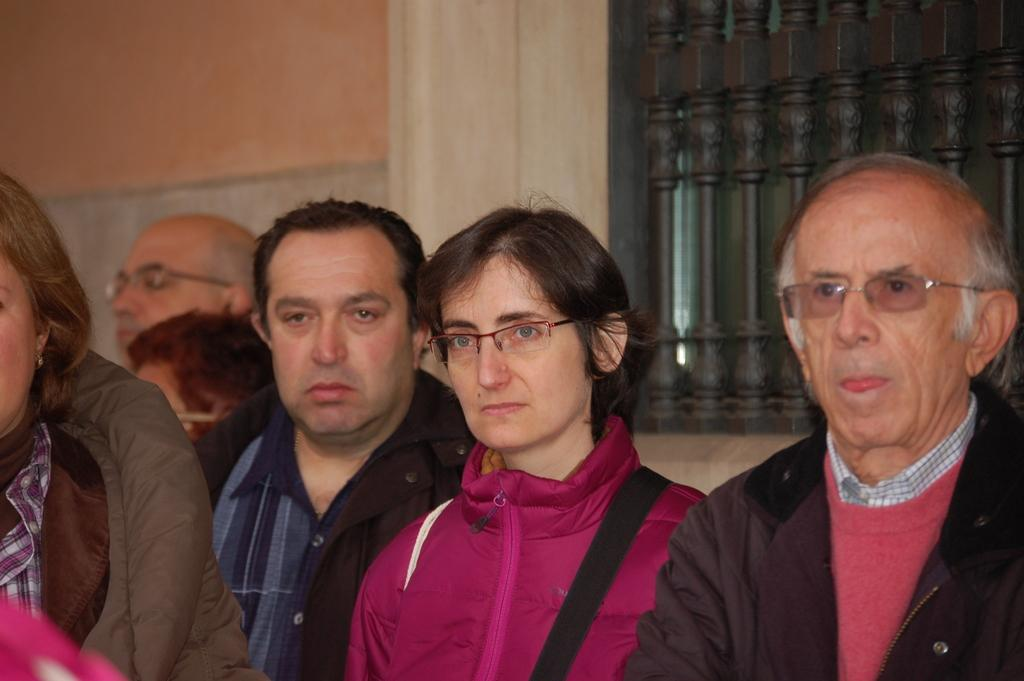How many people are in the image? There is a group of people in the image, but the exact number is not specified. What can be observed about some of the people in the image? Some of the people are wearing spectacles. What can be seen in the background of the image? There is a wall and a railing in the background of the image. What type of zipper can be seen on the cart in the image? There is no cart or zipper present in the image. What color is the yarn being used by the people in the image? There is no yarn or indication of yarn-related activities in the image. 